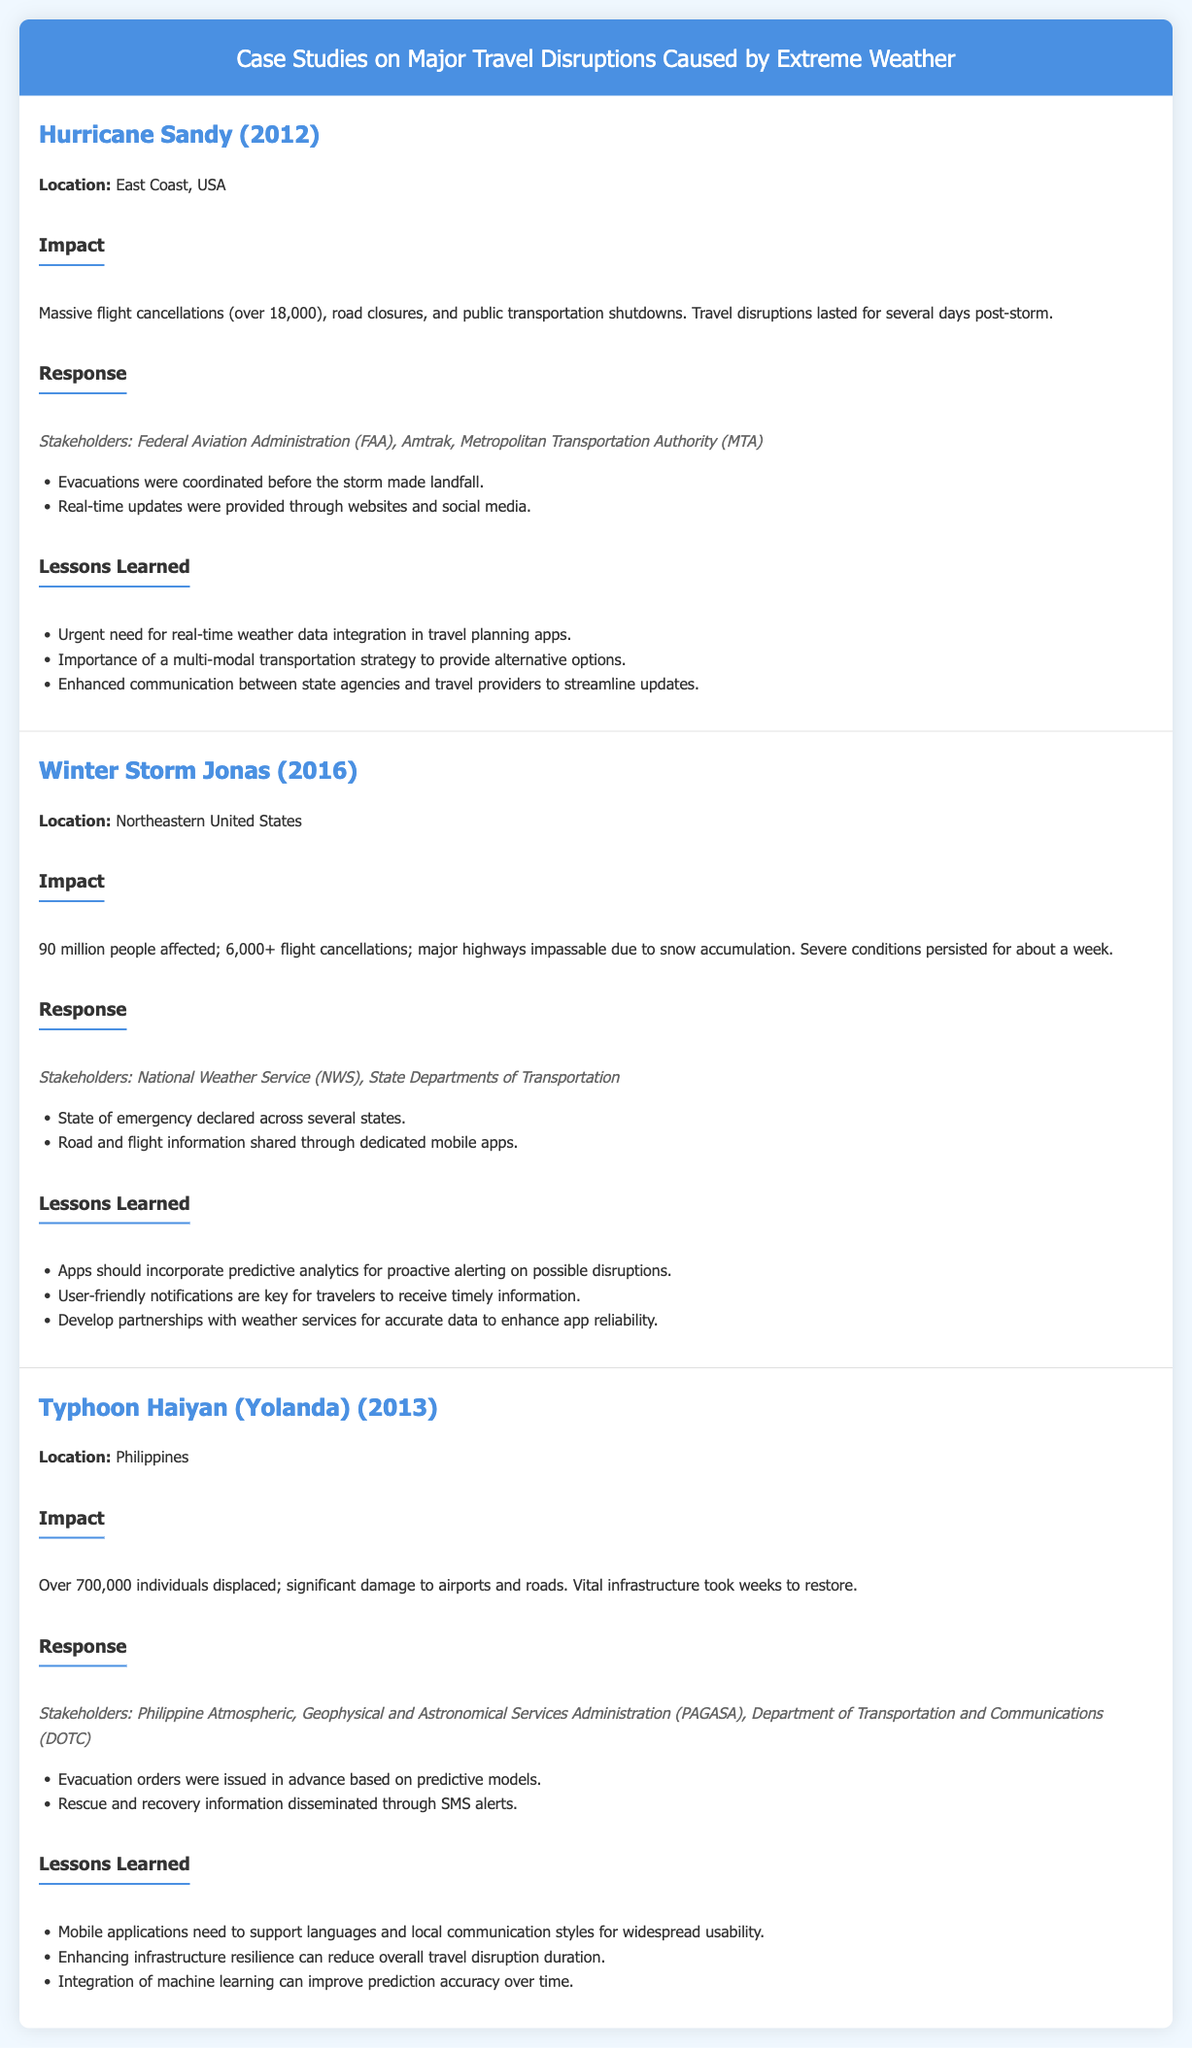What year did Hurricane Sandy occur? The document states that Hurricane Sandy occurred in 2012.
Answer: 2012 How many flights were canceled due to Winter Storm Jonas? According to the document, Winter Storm Jonas led to over 6,000 flight cancellations.
Answer: over 6,000 What was a key lesson learned from Hurricane Sandy? A lesson learned was the urgent need for real-time weather data integration in travel planning apps.
Answer: Real-time weather data integration Which typhoon caused significant travel disruptions in the Philippines? The document mentions Typhoon Haiyan (Yolanda) as causing major disruptions.
Answer: Typhoon Haiyan What was a response to Hurricane Sandy? A response involved providing real-time updates through websites and social media.
Answer: Real-time updates How many people were affected by Winter Storm Jonas? The document states that 90 million people were affected.
Answer: 90 million What is a recommended feature for travel disruption apps based on the case studies? The document suggests that apps should incorporate predictive analytics for proactive alerting.
Answer: Predictive analytics What stakeholder was involved in the response to Typhoon Haiyan? The Philippine Atmospheric, Geophysical and Astronomical Services Administration (PAGASA) was a key stakeholder.
Answer: PAGASA What was a significant impact of Typhoon Haiyan? The document states that over 700,000 individuals were displaced due to the typhoon.
Answer: over 700,000 What type of document is this? The document presents case studies on major travel disruptions caused by extreme weather.
Answer: Case studies 